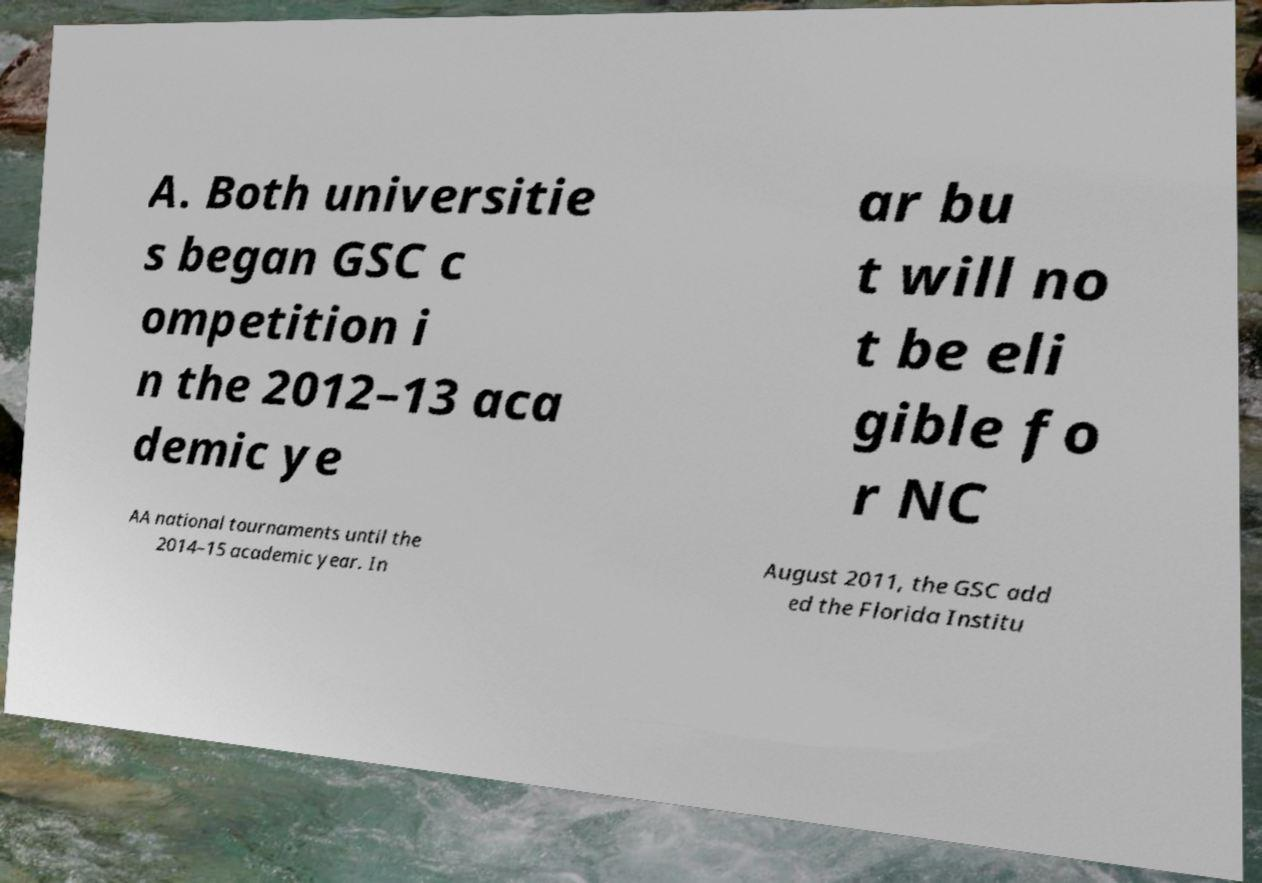Could you extract and type out the text from this image? A. Both universitie s began GSC c ompetition i n the 2012–13 aca demic ye ar bu t will no t be eli gible fo r NC AA national tournaments until the 2014–15 academic year. In August 2011, the GSC add ed the Florida Institu 